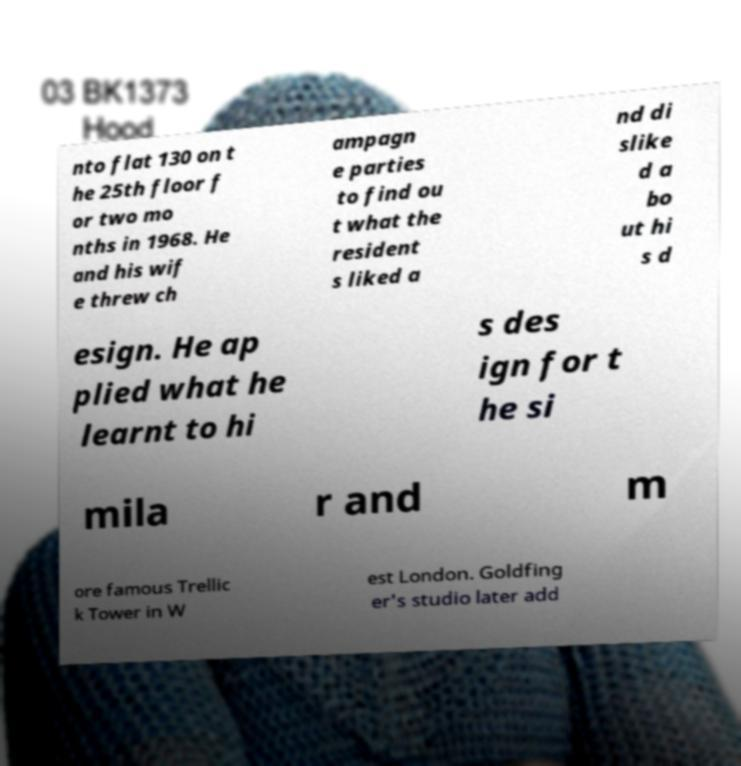Could you extract and type out the text from this image? nto flat 130 on t he 25th floor f or two mo nths in 1968. He and his wif e threw ch ampagn e parties to find ou t what the resident s liked a nd di slike d a bo ut hi s d esign. He ap plied what he learnt to hi s des ign for t he si mila r and m ore famous Trellic k Tower in W est London. Goldfing er's studio later add 